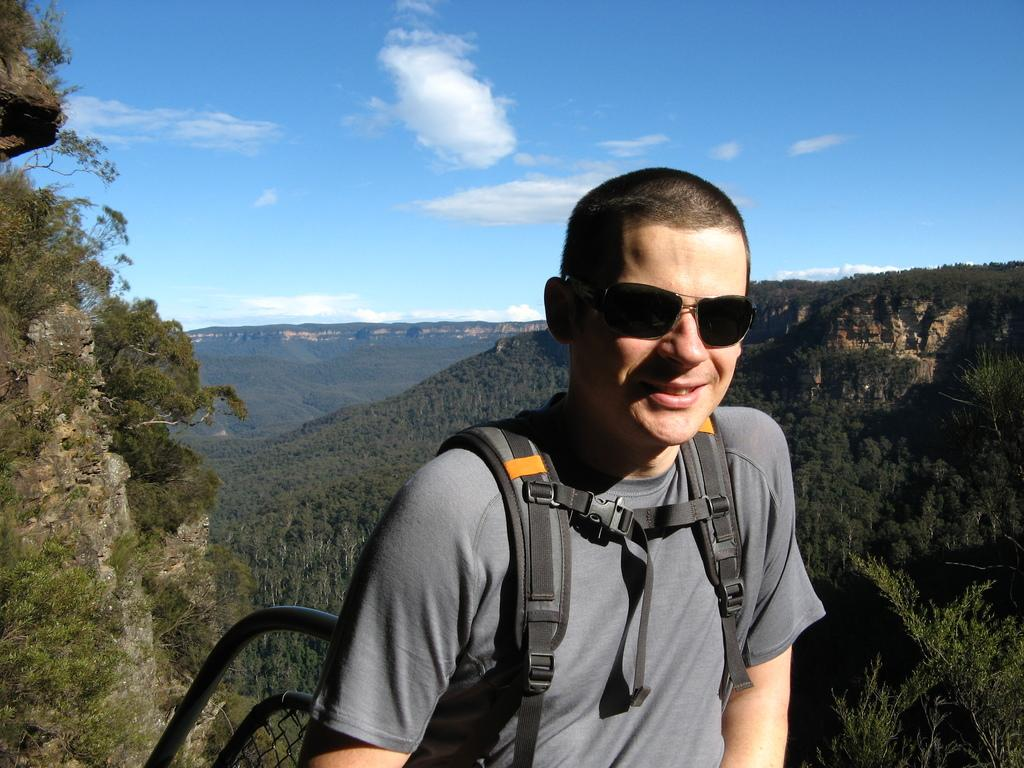Who is present in the image? There is a man in the image. What is the man wearing on his face? The man is wearing goggles. What can be seen behind the man? There is an object behind the man. What type of natural environment is visible in the image? Trees, hills, and the sky are visible in the image. What type of appliance can be seen flying in the sky in the image? There is no appliance visible in the sky in the image; only trees, hills, and the sky are present. 